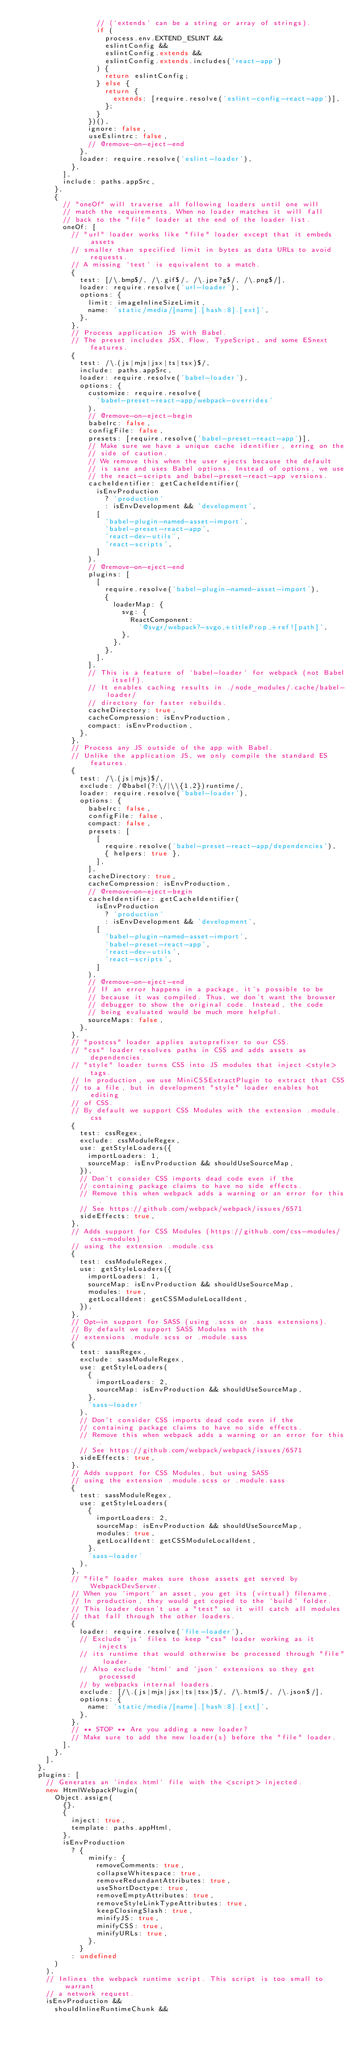Convert code to text. <code><loc_0><loc_0><loc_500><loc_500><_JavaScript_>                  // (`extends` can be a string or array of strings).
                  if (
                    process.env.EXTEND_ESLINT &&
                    eslintConfig &&
                    eslintConfig.extends &&
                    eslintConfig.extends.includes('react-app')
                  ) {
                    return eslintConfig;
                  } else {
                    return {
                      extends: [require.resolve('eslint-config-react-app')],
                    };
                  }
                })(),
                ignore: false,
                useEslintrc: false,
                // @remove-on-eject-end
              },
              loader: require.resolve('eslint-loader'),
            },
          ],
          include: paths.appSrc,
        },
        {
          // "oneOf" will traverse all following loaders until one will
          // match the requirements. When no loader matches it will fall
          // back to the "file" loader at the end of the loader list.
          oneOf: [
            // "url" loader works like "file" loader except that it embeds assets
            // smaller than specified limit in bytes as data URLs to avoid requests.
            // A missing `test` is equivalent to a match.
            {
              test: [/\.bmp$/, /\.gif$/, /\.jpe?g$/, /\.png$/],
              loader: require.resolve('url-loader'),
              options: {
                limit: imageInlineSizeLimit,
                name: 'static/media/[name].[hash:8].[ext]',
              },
            },
            // Process application JS with Babel.
            // The preset includes JSX, Flow, TypeScript, and some ESnext features.
            {
              test: /\.(js|mjs|jsx|ts|tsx)$/,
              include: paths.appSrc,
              loader: require.resolve('babel-loader'),
              options: {
                customize: require.resolve(
                  'babel-preset-react-app/webpack-overrides'
                ),
                // @remove-on-eject-begin
                babelrc: false,
                configFile: false,
                presets: [require.resolve('babel-preset-react-app')],
                // Make sure we have a unique cache identifier, erring on the
                // side of caution.
                // We remove this when the user ejects because the default
                // is sane and uses Babel options. Instead of options, we use
                // the react-scripts and babel-preset-react-app versions.
                cacheIdentifier: getCacheIdentifier(
                  isEnvProduction
                    ? 'production'
                    : isEnvDevelopment && 'development',
                  [
                    'babel-plugin-named-asset-import',
                    'babel-preset-react-app',
                    'react-dev-utils',
                    'react-scripts',
                  ]
                ),
                // @remove-on-eject-end
                plugins: [
                  [
                    require.resolve('babel-plugin-named-asset-import'),
                    {
                      loaderMap: {
                        svg: {
                          ReactComponent:
                            '@svgr/webpack?-svgo,+titleProp,+ref![path]',
                        },
                      },
                    },
                  ],
                ],
                // This is a feature of `babel-loader` for webpack (not Babel itself).
                // It enables caching results in ./node_modules/.cache/babel-loader/
                // directory for faster rebuilds.
                cacheDirectory: true,
                cacheCompression: isEnvProduction,
                compact: isEnvProduction,
              },
            },
            // Process any JS outside of the app with Babel.
            // Unlike the application JS, we only compile the standard ES features.
            {
              test: /\.(js|mjs)$/,
              exclude: /@babel(?:\/|\\{1,2})runtime/,
              loader: require.resolve('babel-loader'),
              options: {
                babelrc: false,
                configFile: false,
                compact: false,
                presets: [
                  [
                    require.resolve('babel-preset-react-app/dependencies'),
                    { helpers: true },
                  ],
                ],
                cacheDirectory: true,
                cacheCompression: isEnvProduction,
                // @remove-on-eject-begin
                cacheIdentifier: getCacheIdentifier(
                  isEnvProduction
                    ? 'production'
                    : isEnvDevelopment && 'development',
                  [
                    'babel-plugin-named-asset-import',
                    'babel-preset-react-app',
                    'react-dev-utils',
                    'react-scripts',
                  ]
                ),
                // @remove-on-eject-end
                // If an error happens in a package, it's possible to be
                // because it was compiled. Thus, we don't want the browser
                // debugger to show the original code. Instead, the code
                // being evaluated would be much more helpful.
                sourceMaps: false,
              },
            },
            // "postcss" loader applies autoprefixer to our CSS.
            // "css" loader resolves paths in CSS and adds assets as dependencies.
            // "style" loader turns CSS into JS modules that inject <style> tags.
            // In production, we use MiniCSSExtractPlugin to extract that CSS
            // to a file, but in development "style" loader enables hot editing
            // of CSS.
            // By default we support CSS Modules with the extension .module.css
            {
              test: cssRegex,
              exclude: cssModuleRegex,
              use: getStyleLoaders({
                importLoaders: 1,
                sourceMap: isEnvProduction && shouldUseSourceMap,
              }),
              // Don't consider CSS imports dead code even if the
              // containing package claims to have no side effects.
              // Remove this when webpack adds a warning or an error for this.
              // See https://github.com/webpack/webpack/issues/6571
              sideEffects: true,
            },
            // Adds support for CSS Modules (https://github.com/css-modules/css-modules)
            // using the extension .module.css
            {
              test: cssModuleRegex,
              use: getStyleLoaders({
                importLoaders: 1,
                sourceMap: isEnvProduction && shouldUseSourceMap,
                modules: true,
                getLocalIdent: getCSSModuleLocalIdent,
              }),
            },
            // Opt-in support for SASS (using .scss or .sass extensions).
            // By default we support SASS Modules with the
            // extensions .module.scss or .module.sass
            {
              test: sassRegex,
              exclude: sassModuleRegex,
              use: getStyleLoaders(
                {
                  importLoaders: 2,
                  sourceMap: isEnvProduction && shouldUseSourceMap,
                },
                'sass-loader'
              ),
              // Don't consider CSS imports dead code even if the
              // containing package claims to have no side effects.
              // Remove this when webpack adds a warning or an error for this.
              // See https://github.com/webpack/webpack/issues/6571
              sideEffects: true,
            },
            // Adds support for CSS Modules, but using SASS
            // using the extension .module.scss or .module.sass
            {
              test: sassModuleRegex,
              use: getStyleLoaders(
                {
                  importLoaders: 2,
                  sourceMap: isEnvProduction && shouldUseSourceMap,
                  modules: true,
                  getLocalIdent: getCSSModuleLocalIdent,
                },
                'sass-loader'
              ),
            },
            // "file" loader makes sure those assets get served by WebpackDevServer.
            // When you `import` an asset, you get its (virtual) filename.
            // In production, they would get copied to the `build` folder.
            // This loader doesn't use a "test" so it will catch all modules
            // that fall through the other loaders.
            {
              loader: require.resolve('file-loader'),
              // Exclude `js` files to keep "css" loader working as it injects
              // its runtime that would otherwise be processed through "file" loader.
              // Also exclude `html` and `json` extensions so they get processed
              // by webpacks internal loaders.
              exclude: [/\.(js|mjs|jsx|ts|tsx)$/, /\.html$/, /\.json$/],
              options: {
                name: 'static/media/[name].[hash:8].[ext]',
              },
            },
            // ** STOP ** Are you adding a new loader?
            // Make sure to add the new loader(s) before the "file" loader.
          ],
        },
      ],
    },
    plugins: [
      // Generates an `index.html` file with the <script> injected.
      new HtmlWebpackPlugin(
        Object.assign(
          {},
          {
            inject: true,
            template: paths.appHtml,
          },
          isEnvProduction
            ? {
                minify: {
                  removeComments: true,
                  collapseWhitespace: true,
                  removeRedundantAttributes: true,
                  useShortDoctype: true,
                  removeEmptyAttributes: true,
                  removeStyleLinkTypeAttributes: true,
                  keepClosingSlash: true,
                  minifyJS: true,
                  minifyCSS: true,
                  minifyURLs: true,
                },
              }
            : undefined
        )
      ),
      // Inlines the webpack runtime script. This script is too small to warrant
      // a network request.
      isEnvProduction &&
        shouldInlineRuntimeChunk &&</code> 